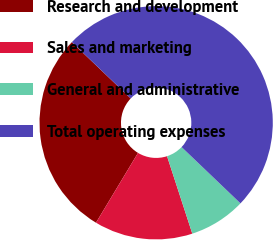Convert chart to OTSL. <chart><loc_0><loc_0><loc_500><loc_500><pie_chart><fcel>Research and development<fcel>Sales and marketing<fcel>General and administrative<fcel>Total operating expenses<nl><fcel>28.52%<fcel>13.64%<fcel>7.84%<fcel>50.0%<nl></chart> 